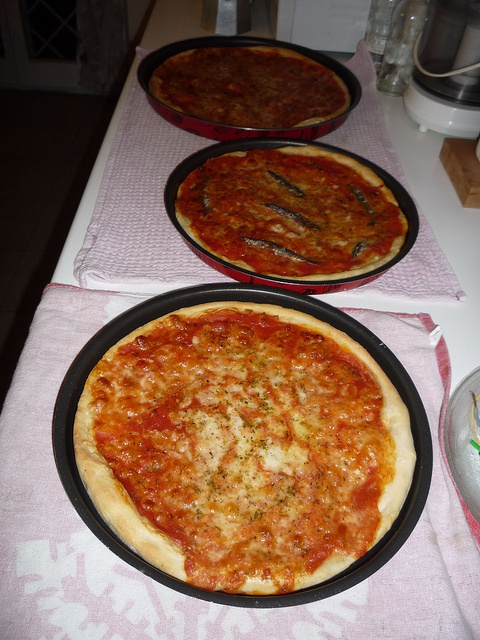Describe the objects in this image and their specific colors. I can see dining table in black, lightgray, red, and maroon tones, pizza in black, red, tan, and brown tones, pizza in black, maroon, and olive tones, pizza in black, maroon, and gray tones, and bottle in black and gray tones in this image. 